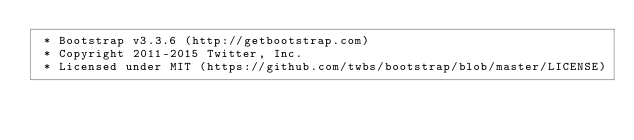Convert code to text. <code><loc_0><loc_0><loc_500><loc_500><_CSS_> * Bootstrap v3.3.6 (http://getbootstrap.com)
 * Copyright 2011-2015 Twitter, Inc.
 * Licensed under MIT (https://github.com/twbs/bootstrap/blob/master/LICENSE)</code> 